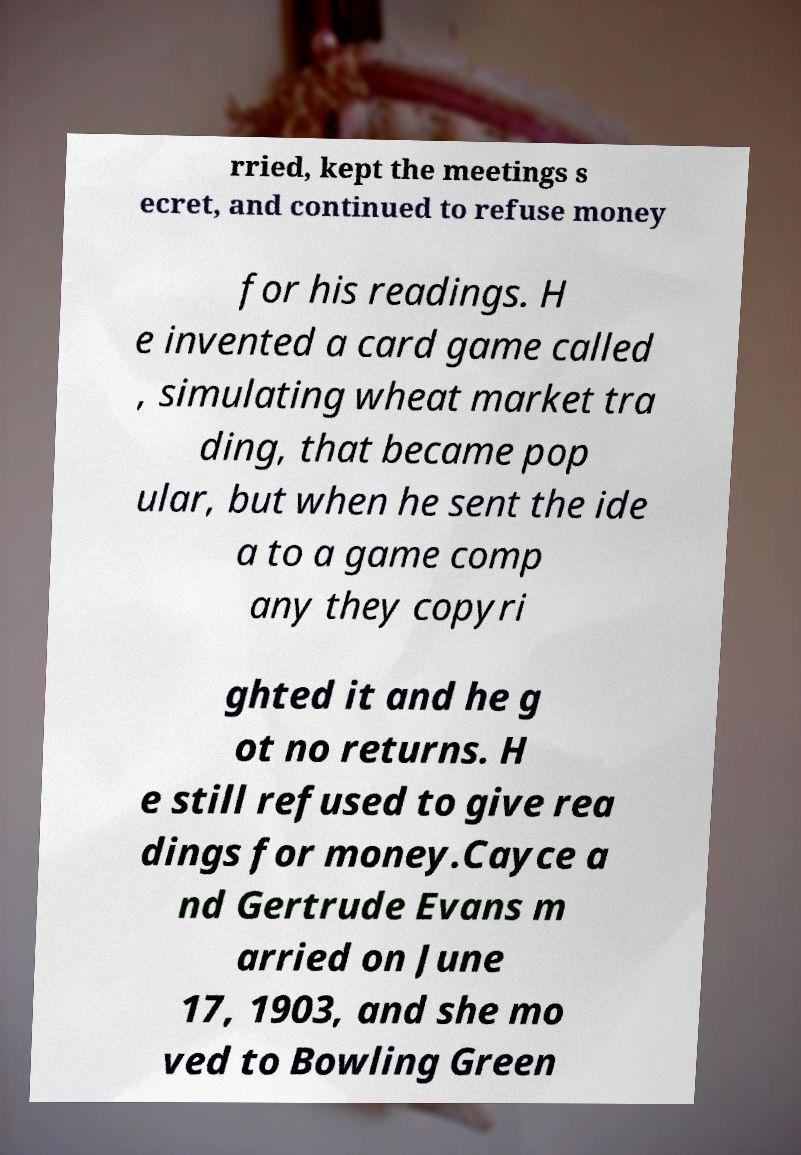Please read and relay the text visible in this image. What does it say? rried, kept the meetings s ecret, and continued to refuse money for his readings. H e invented a card game called , simulating wheat market tra ding, that became pop ular, but when he sent the ide a to a game comp any they copyri ghted it and he g ot no returns. H e still refused to give rea dings for money.Cayce a nd Gertrude Evans m arried on June 17, 1903, and she mo ved to Bowling Green 